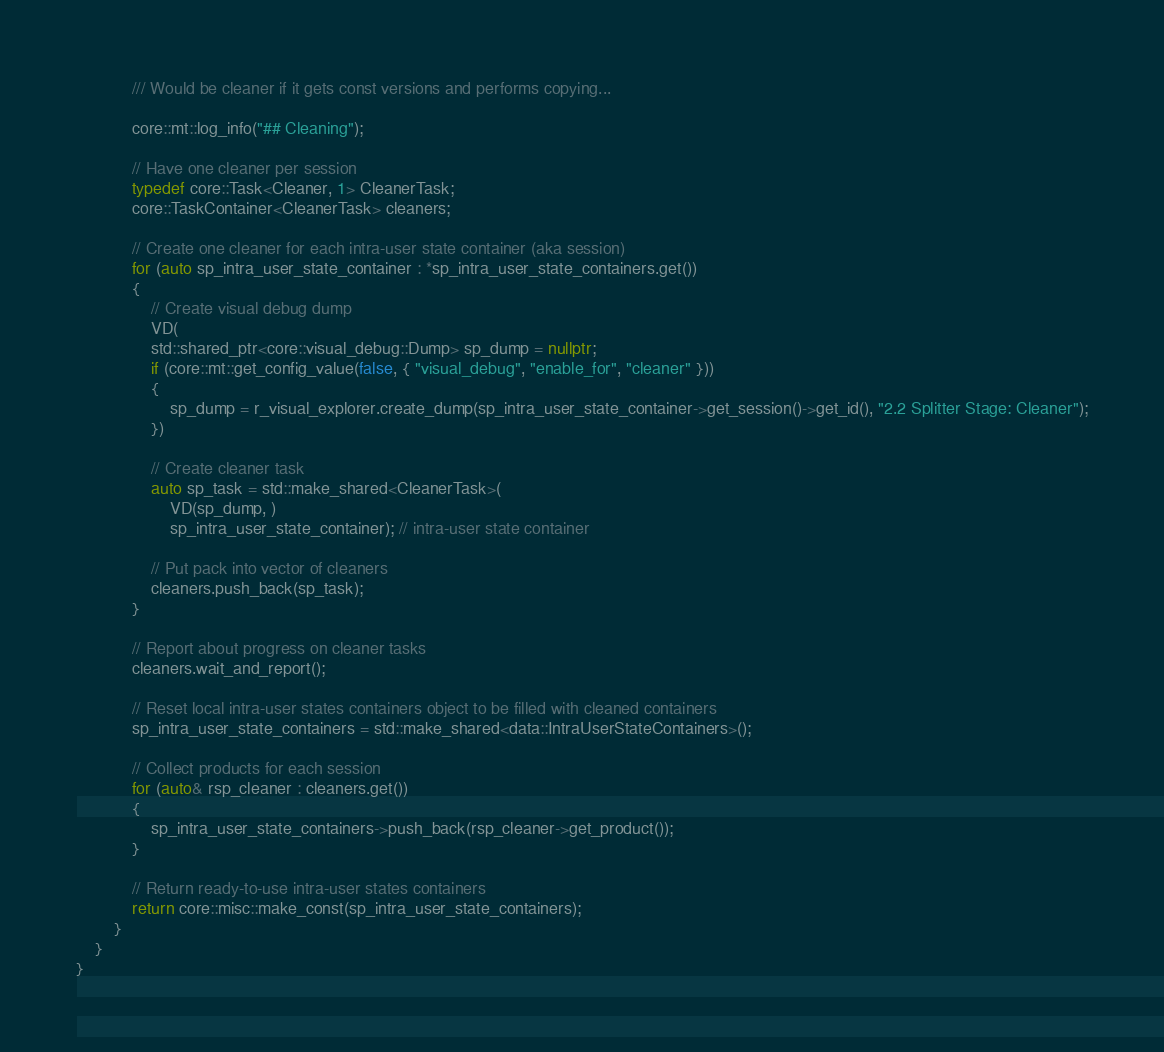<code> <loc_0><loc_0><loc_500><loc_500><_C++_>			/// Would be cleaner if it gets const versions and performs copying...

			core::mt::log_info("## Cleaning");

			// Have one cleaner per session
			typedef core::Task<Cleaner, 1> CleanerTask;
			core::TaskContainer<CleanerTask> cleaners;
			
			// Create one cleaner for each intra-user state container (aka session)
			for (auto sp_intra_user_state_container : *sp_intra_user_state_containers.get())
			{
				// Create visual debug dump
				VD(
				std::shared_ptr<core::visual_debug::Dump> sp_dump = nullptr;
				if (core::mt::get_config_value(false, { "visual_debug", "enable_for", "cleaner" }))
				{
					sp_dump = r_visual_explorer.create_dump(sp_intra_user_state_container->get_session()->get_id(), "2.2 Splitter Stage: Cleaner");
				})

				// Create cleaner task
				auto sp_task = std::make_shared<CleanerTask>(
					VD(sp_dump, )
					sp_intra_user_state_container); // intra-user state container

				// Put pack into vector of cleaners
				cleaners.push_back(sp_task);
			}

			// Report about progress on cleaner tasks
			cleaners.wait_and_report();

			// Reset local intra-user states containers object to be filled with cleaned containers
			sp_intra_user_state_containers = std::make_shared<data::IntraUserStateContainers>();
			
			// Collect products for each session
			for (auto& rsp_cleaner : cleaners.get())
			{
				sp_intra_user_state_containers->push_back(rsp_cleaner->get_product());
			}

			// Return ready-to-use intra-user states containers
			return core::misc::make_const(sp_intra_user_state_containers);
		}
	}
}
</code> 